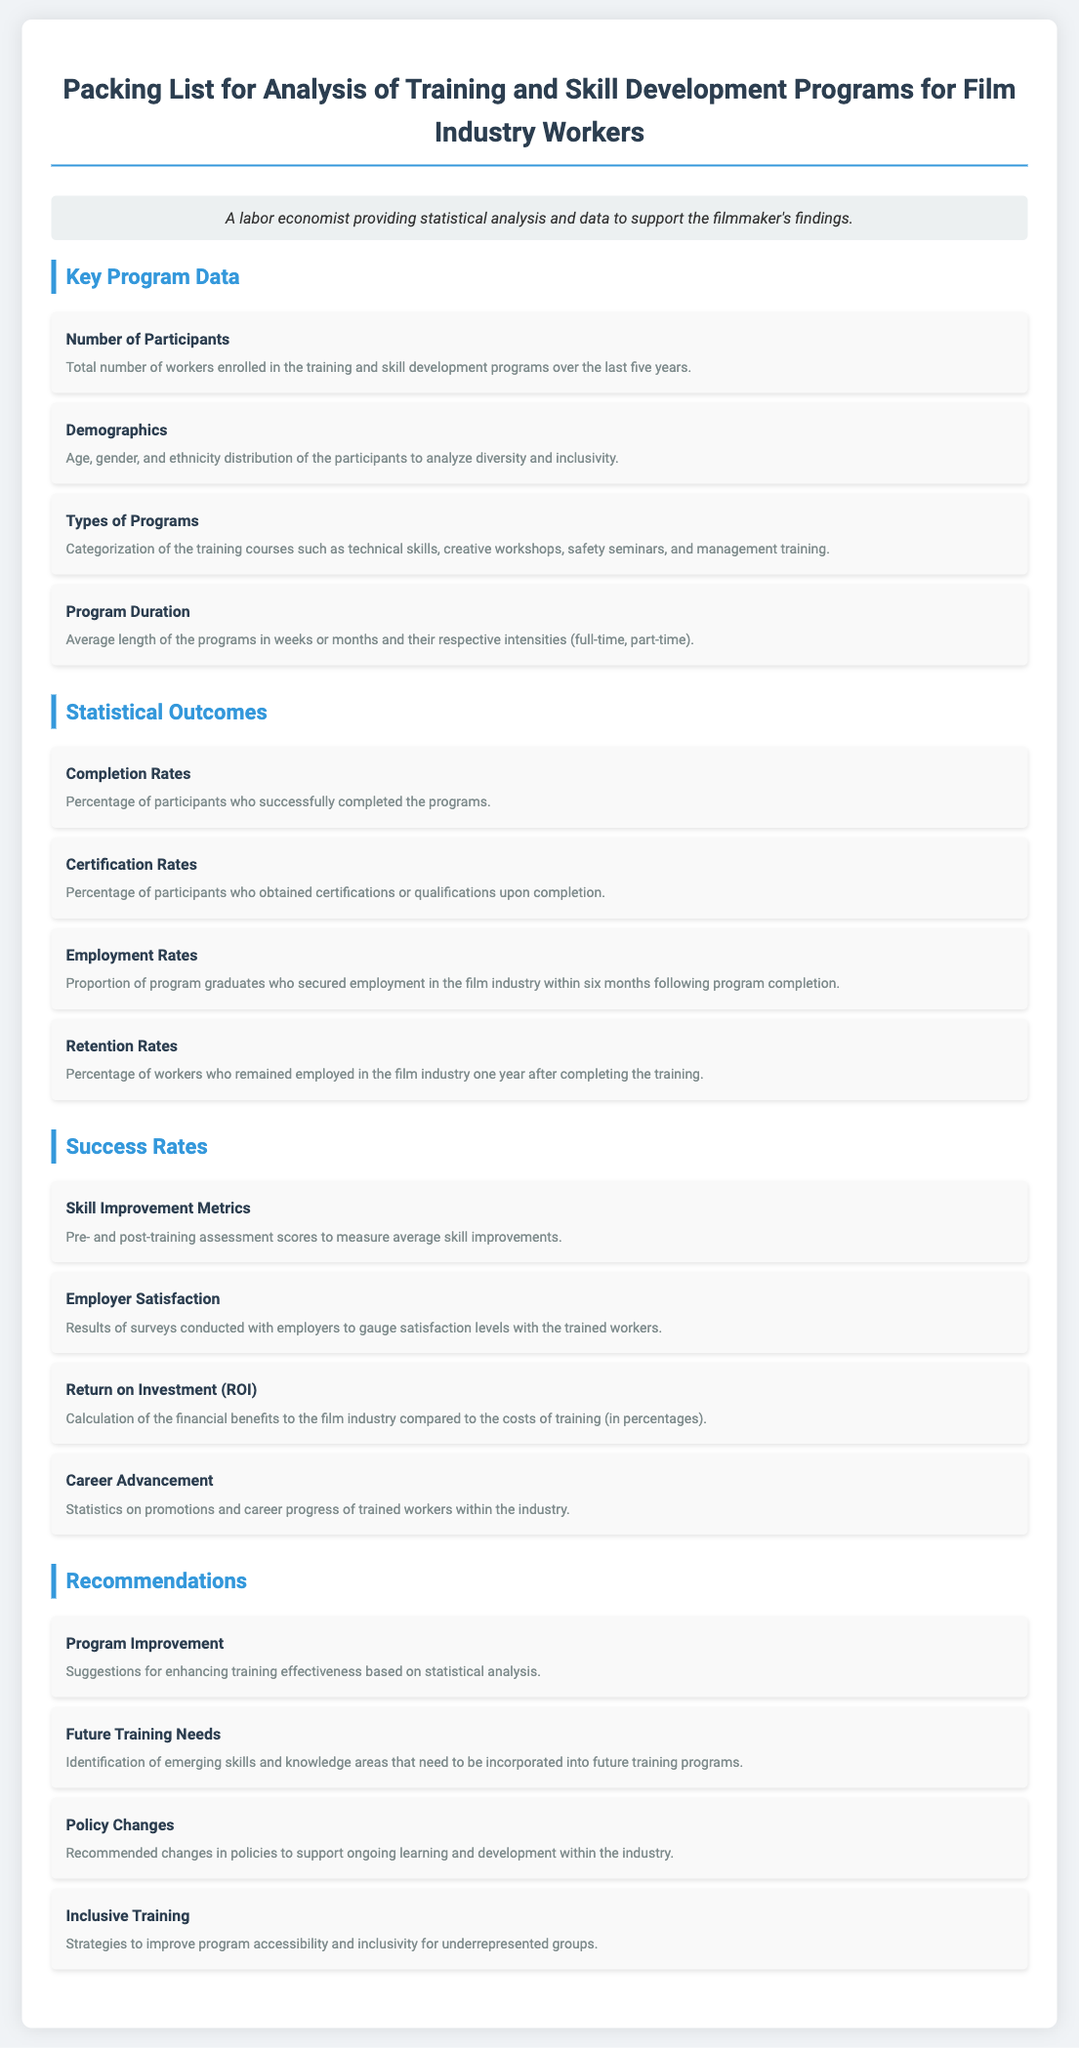What is the total number of participants? The total number of workers enrolled in the training and skill development programs over the last five years is stated in the key program data section.
Answer: Number of Participants What types of programs are included? The types of programs are categorized in the key program data section as mentioned in the document.
Answer: Technical skills, creative workshops, safety seminars, management training What is the average length of the programs? The average length of the programs is described under program duration, providing information about their lengths in weeks or months.
Answer: Program Duration What is the completion rate percentage? The completion rates are outlined as the percentage of participants who successfully completed the programs as per the statistical outcomes section.
Answer: Completion Rates What are the skill improvement metrics? Skill improvement metrics are detailed under success rates as pre- and post-training assessment scores to measure average skill improvements.
Answer: Skill Improvement Metrics What is the focus of the program improvement recommendations? Program improvement suggestions are found in the recommendations section, aimed at enhancing training effectiveness based on statistical analysis.
Answer: Program Improvement What does employer satisfaction measure? Employer satisfaction is described as survey results conducted with employers to gauge satisfaction levels with the trained workers under success rates.
Answer: Employer Satisfaction What should be prioritized for future training needs? Future training needs are identified in the recommendations section where emerging skills and knowledge areas are highlighted to be incorporated into training programs.
Answer: Future Training Needs What is the emphasis of inclusive training recommendations? Inclusive training strategies aim to improve program accessibility and inclusivity for underrepresented groups according to the recommendations.
Answer: Inclusive Training 